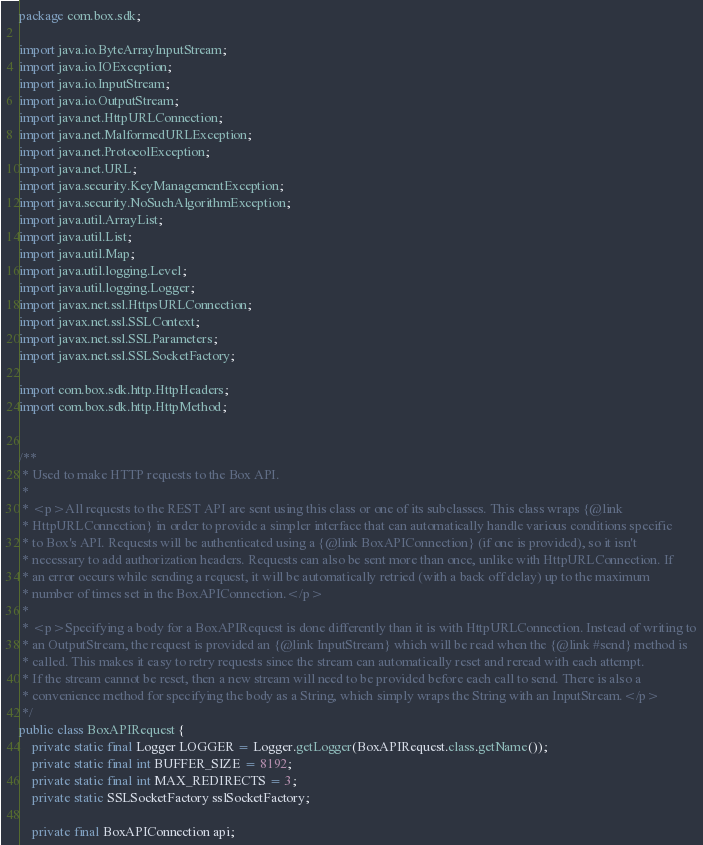<code> <loc_0><loc_0><loc_500><loc_500><_Java_>package com.box.sdk;

import java.io.ByteArrayInputStream;
import java.io.IOException;
import java.io.InputStream;
import java.io.OutputStream;
import java.net.HttpURLConnection;
import java.net.MalformedURLException;
import java.net.ProtocolException;
import java.net.URL;
import java.security.KeyManagementException;
import java.security.NoSuchAlgorithmException;
import java.util.ArrayList;
import java.util.List;
import java.util.Map;
import java.util.logging.Level;
import java.util.logging.Logger;
import javax.net.ssl.HttpsURLConnection;
import javax.net.ssl.SSLContext;
import javax.net.ssl.SSLParameters;
import javax.net.ssl.SSLSocketFactory;

import com.box.sdk.http.HttpHeaders;
import com.box.sdk.http.HttpMethod;


/**
 * Used to make HTTP requests to the Box API.
 *
 * <p>All requests to the REST API are sent using this class or one of its subclasses. This class wraps {@link
 * HttpURLConnection} in order to provide a simpler interface that can automatically handle various conditions specific
 * to Box's API. Requests will be authenticated using a {@link BoxAPIConnection} (if one is provided), so it isn't
 * necessary to add authorization headers. Requests can also be sent more than once, unlike with HttpURLConnection. If
 * an error occurs while sending a request, it will be automatically retried (with a back off delay) up to the maximum
 * number of times set in the BoxAPIConnection.</p>
 *
 * <p>Specifying a body for a BoxAPIRequest is done differently than it is with HttpURLConnection. Instead of writing to
 * an OutputStream, the request is provided an {@link InputStream} which will be read when the {@link #send} method is
 * called. This makes it easy to retry requests since the stream can automatically reset and reread with each attempt.
 * If the stream cannot be reset, then a new stream will need to be provided before each call to send. There is also a
 * convenience method for specifying the body as a String, which simply wraps the String with an InputStream.</p>
 */
public class BoxAPIRequest {
    private static final Logger LOGGER = Logger.getLogger(BoxAPIRequest.class.getName());
    private static final int BUFFER_SIZE = 8192;
    private static final int MAX_REDIRECTS = 3;
    private static SSLSocketFactory sslSocketFactory;

    private final BoxAPIConnection api;</code> 